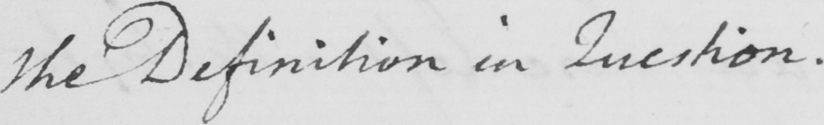Can you read and transcribe this handwriting? the Definition in Question . 